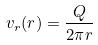<formula> <loc_0><loc_0><loc_500><loc_500>v _ { r } ( r ) = \frac { Q } { 2 \pi r }</formula> 